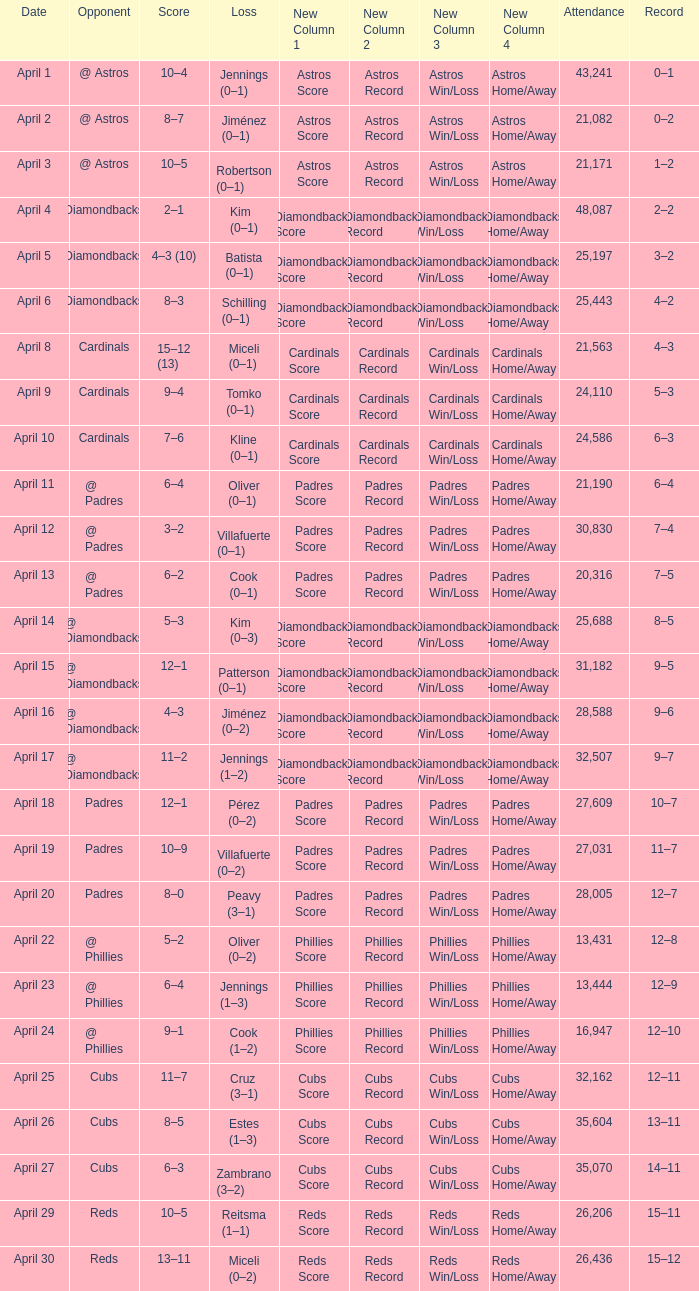What is the team's record on april 23? 12–9. 